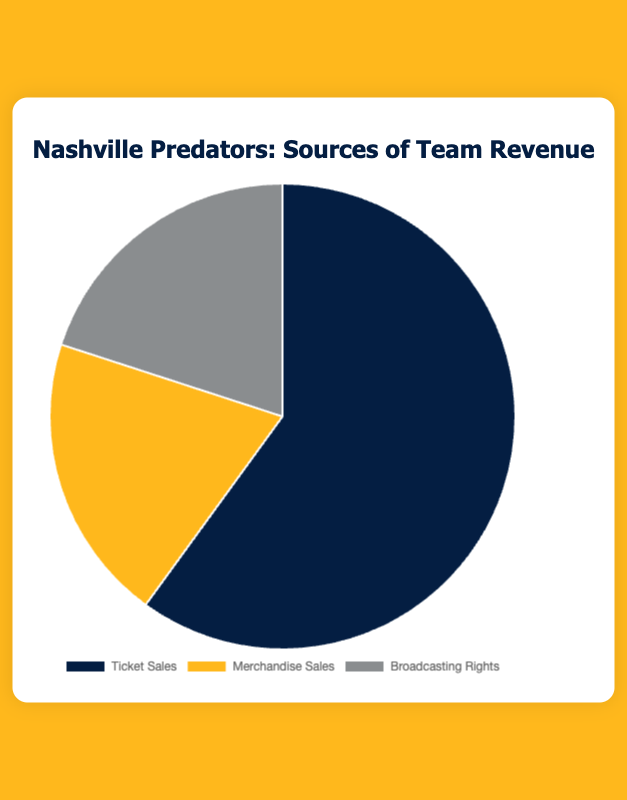what percentage of the revenue comes from merchandise sales? The chart shows that merchandise sales account for 20% of the revenue.
Answer: 20% Which revenue source contributes the most to the total revenue? The chart shows that ticket sales contribute 60% to the total revenue, which is the highest percentage among the three categories.
Answer: Ticket Sales What is the combined revenue percentage from merchandise sales and broadcasting rights? The chart shows that merchandise sales contribute 20% and broadcasting rights contribute 20% to the total revenue. The combined percentage is 20% + 20% = 40%.
Answer: 40% Compare the revenue percentages between ticket sales and broadcasting rights. Which is higher and by how much? Ticket sales contribute 60% and broadcasting rights contribute 20%. The difference is 60% - 20% = 40%.
Answer: Ticket sales by 40% What is the difference between the revenue percentage of merchandise sales and broadcasting rights? Both merchandise sales and broadcasting rights each contribute 20% to the total revenue. Therefore, the difference is 20% - 20% = 0%.
Answer: 0% Which category or categories contribute the least to team revenue? The chart shows that both merchandise sales and broadcasting rights each contribute 20% to the total revenue, which are the lowest percentages among the three categories.
Answer: Merchandise Sales and Broadcasting Rights What's the total percentage contribution of categories other than ticket sales? Merchandise sales and broadcasting rights each contribute 20%. The combined percentage for these two categories other than ticket sales is 20% + 20% = 40%.
Answer: 40% What color is used to represent merchandise sales in the chart? In the chart, merchandise sales are represented in yellow.
Answer: Yellow 